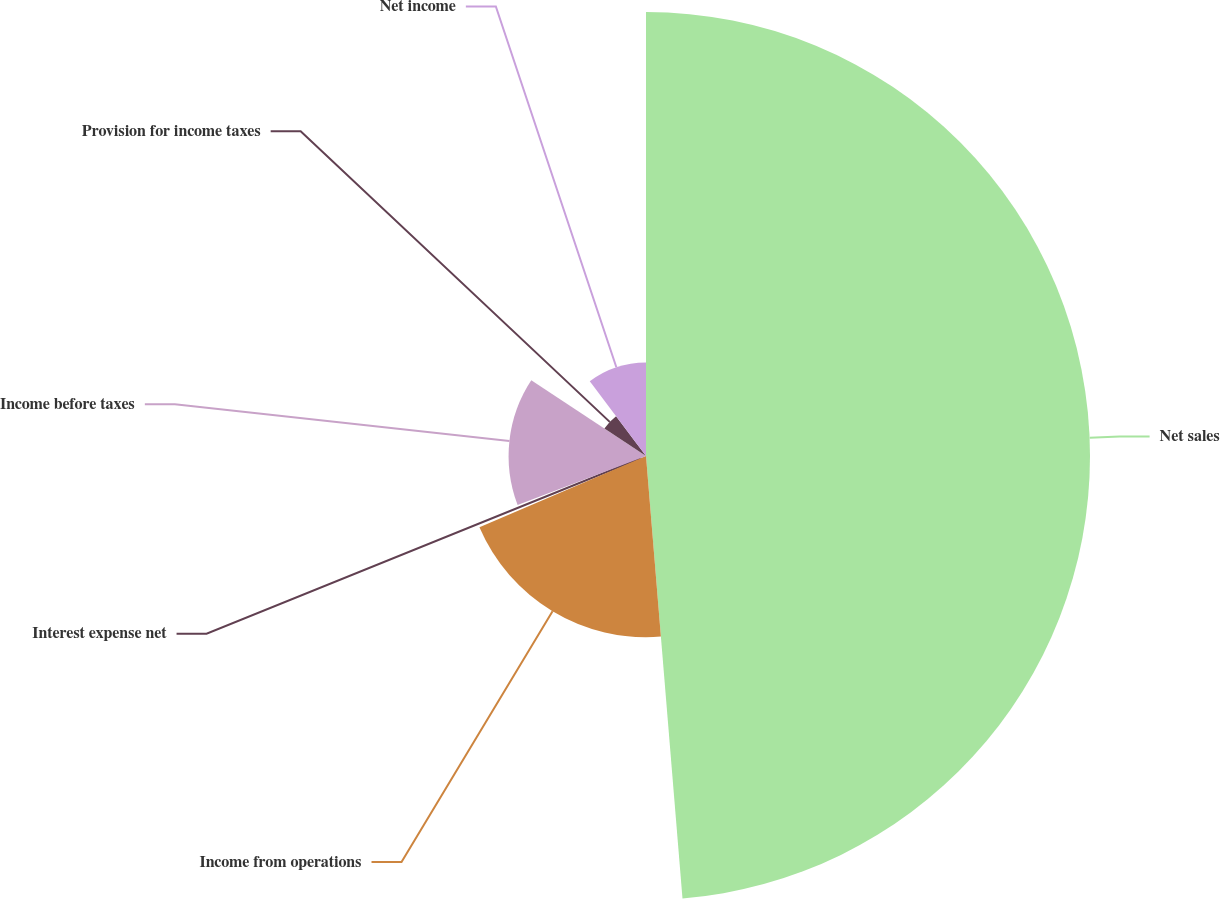<chart> <loc_0><loc_0><loc_500><loc_500><pie_chart><fcel>Net sales<fcel>Income from operations<fcel>Interest expense net<fcel>Income before taxes<fcel>Provision for income taxes<fcel>Net income<nl><fcel>48.69%<fcel>19.87%<fcel>0.65%<fcel>15.07%<fcel>5.46%<fcel>10.26%<nl></chart> 